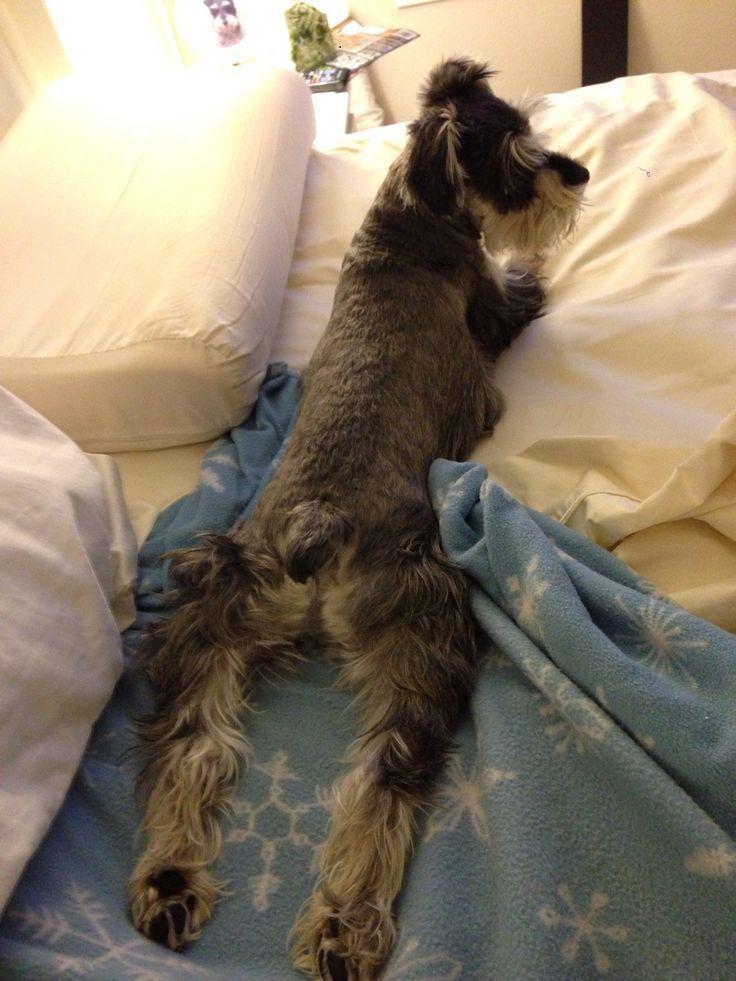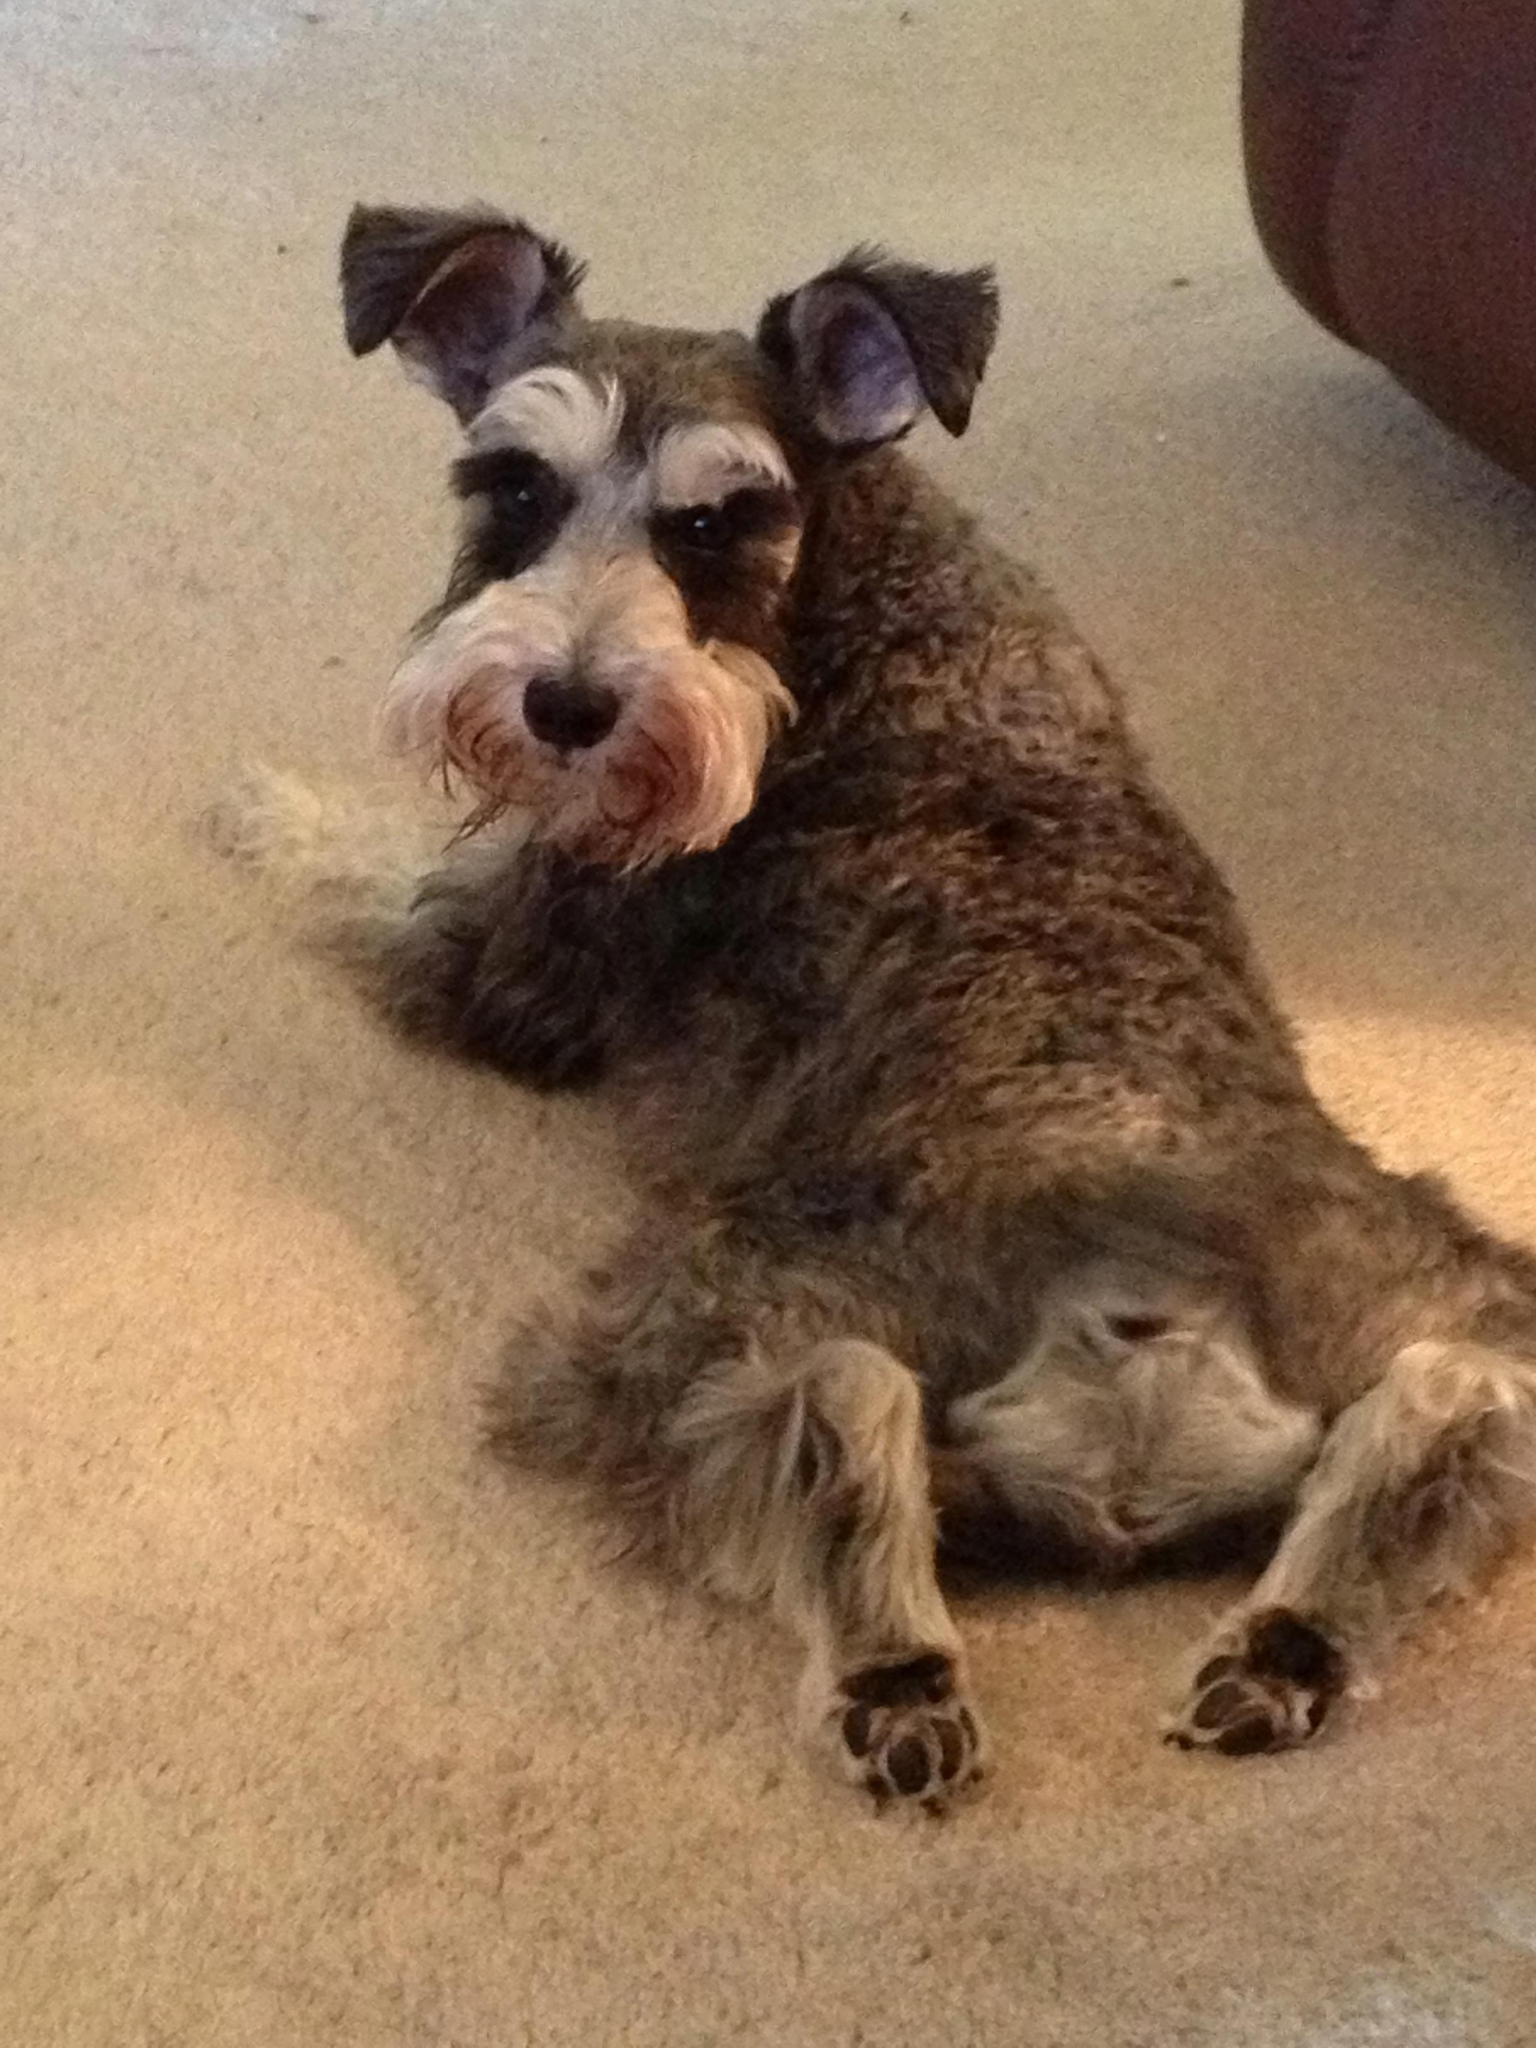The first image is the image on the left, the second image is the image on the right. Analyze the images presented: Is the assertion "The left image shows a schnauzer with its rear to the camera, lying on its belly on a pillow, with its legs extended behind it and its head turned to the right." valid? Answer yes or no. Yes. The first image is the image on the left, the second image is the image on the right. Examine the images to the left and right. Is the description "All the dogs are laying on their stomachs." accurate? Answer yes or no. Yes. 